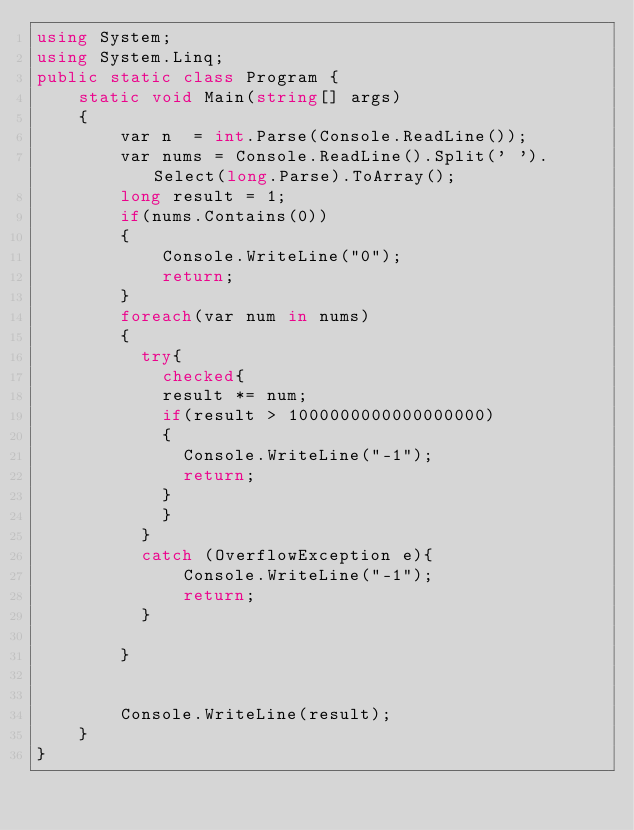Convert code to text. <code><loc_0><loc_0><loc_500><loc_500><_C#_>using System;
using System.Linq;
public static class Program {
    static void Main(string[] args)
    {
        var n  = int.Parse(Console.ReadLine());
        var nums = Console.ReadLine().Split(' ').Select(long.Parse).ToArray();
        long result = 1;
        if(nums.Contains(0))
        {
            Console.WriteLine("0");
            return;
        }
        foreach(var num in nums)
        {
          try{
            checked{
            result *= num; 
            if(result > 1000000000000000000)
            {
              Console.WriteLine("-1");
              return;
            }
            }
          }
          catch (OverflowException e){
              Console.WriteLine("-1");
              return;
          }
          
        }
       
       
        Console.WriteLine(result);
    }
}</code> 